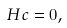<formula> <loc_0><loc_0><loc_500><loc_500>H c = 0 ,</formula> 